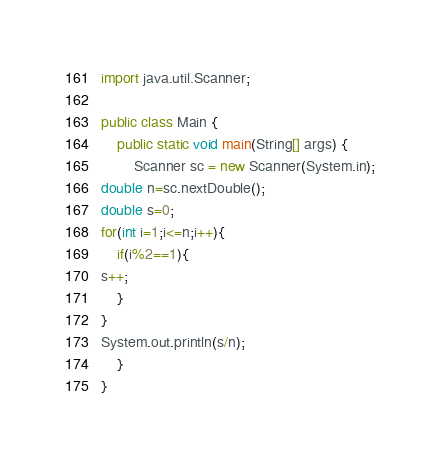<code> <loc_0><loc_0><loc_500><loc_500><_Java_>import java.util.Scanner;

public class Main {
	public static void main(String[] args) {
		Scanner sc = new Scanner(System.in);
double n=sc.nextDouble();
double s=0;
for(int i=1;i<=n;i++){
	if(i%2==1){
s++;
	}
}
System.out.println(s/n);
	}
}</code> 